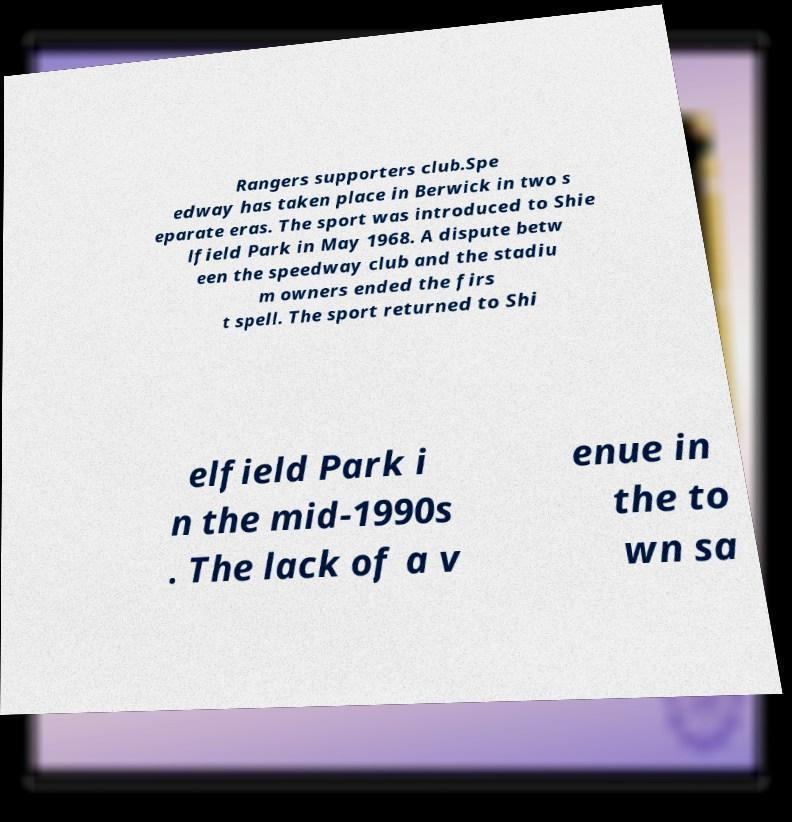For documentation purposes, I need the text within this image transcribed. Could you provide that? Rangers supporters club.Spe edway has taken place in Berwick in two s eparate eras. The sport was introduced to Shie lfield Park in May 1968. A dispute betw een the speedway club and the stadiu m owners ended the firs t spell. The sport returned to Shi elfield Park i n the mid-1990s . The lack of a v enue in the to wn sa 